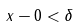Convert formula to latex. <formula><loc_0><loc_0><loc_500><loc_500>x - 0 < \delta</formula> 